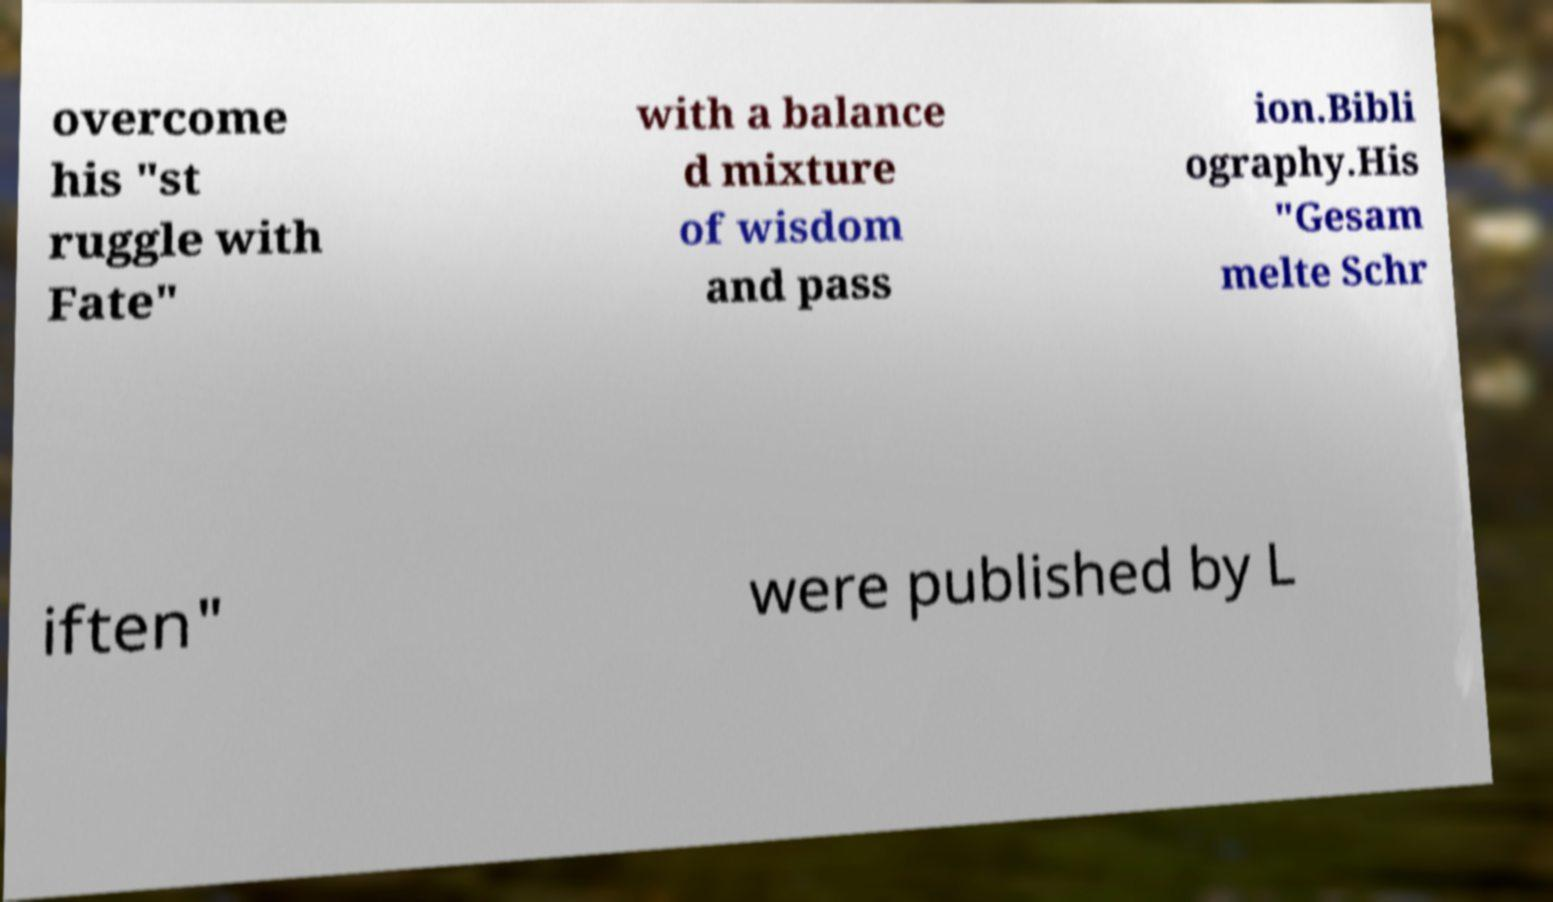Can you accurately transcribe the text from the provided image for me? overcome his "st ruggle with Fate" with a balance d mixture of wisdom and pass ion.Bibli ography.His "Gesam melte Schr iften" were published by L 